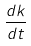<formula> <loc_0><loc_0><loc_500><loc_500>\frac { d k } { d t }</formula> 